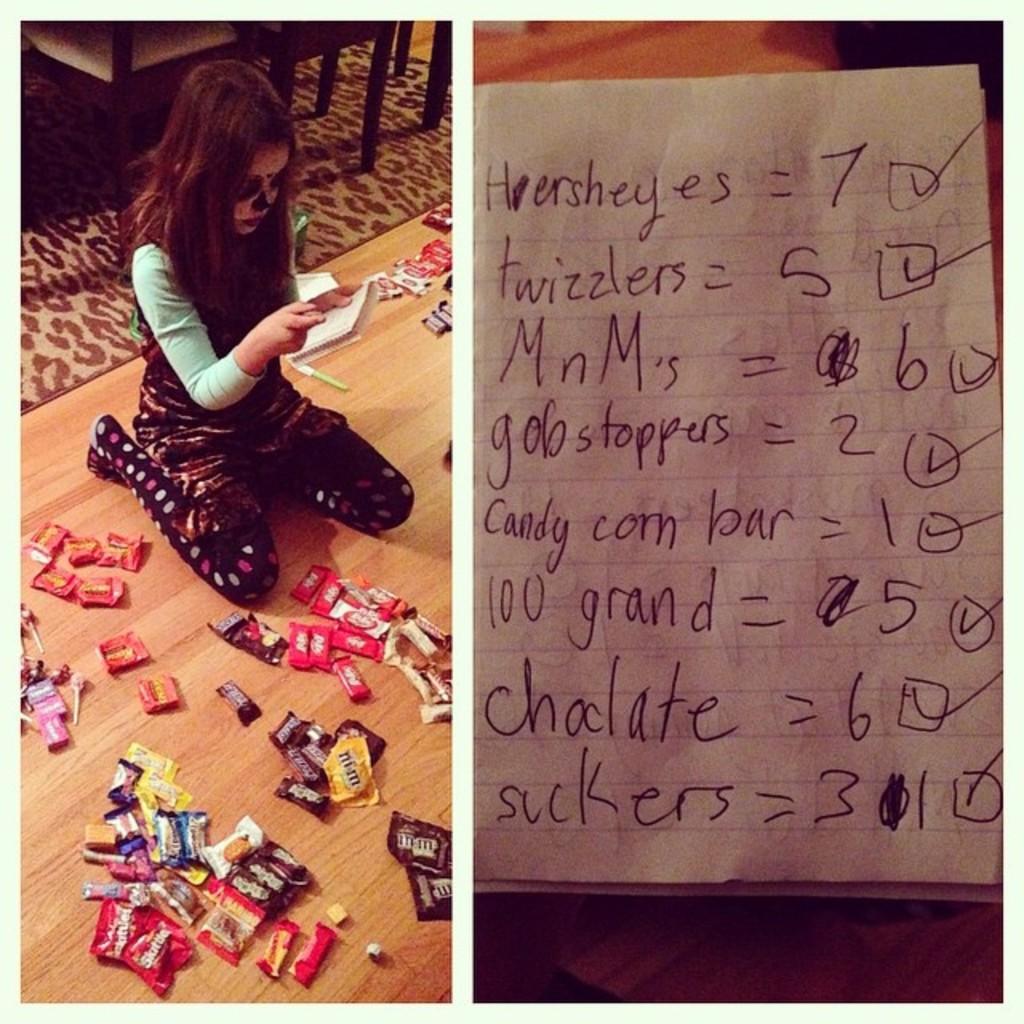In one or two sentences, can you explain what this image depicts? In this image we can see two pictures on the right side, we can see a paper with text on it. On the left side, we can see a person sitting on the floor and holding a paper and to the side we can see some chocolates around. In the background, we can see some chairs. 